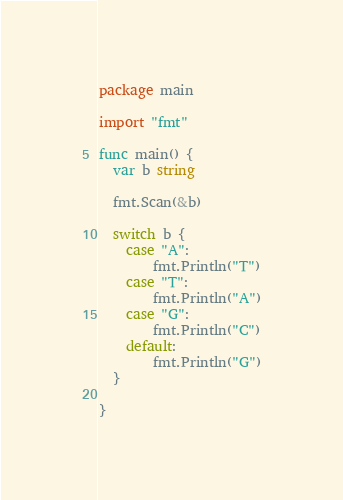Convert code to text. <code><loc_0><loc_0><loc_500><loc_500><_Go_>package main
 
import "fmt"
 
func main() {
  var b string
 
  fmt.Scan(&b)
  
  switch b {
    case "A": 
    	fmt.Println("T")
    case "T":
    	fmt.Println("A")
    case "G":
    	fmt.Println("C")
    default:
    	fmt.Println("G")
  }
  
}</code> 